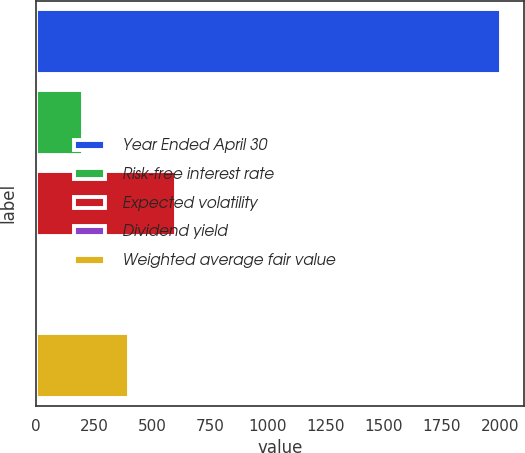Convert chart. <chart><loc_0><loc_0><loc_500><loc_500><bar_chart><fcel>Year Ended April 30<fcel>Risk-free interest rate<fcel>Expected volatility<fcel>Dividend yield<fcel>Weighted average fair value<nl><fcel>2004<fcel>201.87<fcel>602.35<fcel>1.63<fcel>402.11<nl></chart> 